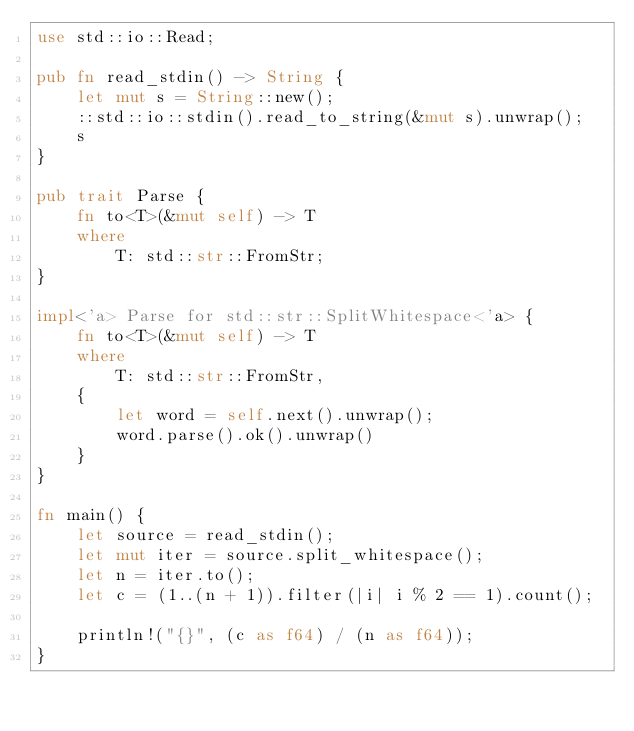Convert code to text. <code><loc_0><loc_0><loc_500><loc_500><_Rust_>use std::io::Read;

pub fn read_stdin() -> String {
    let mut s = String::new();
    ::std::io::stdin().read_to_string(&mut s).unwrap();
    s
}

pub trait Parse {
    fn to<T>(&mut self) -> T
    where
        T: std::str::FromStr;
}

impl<'a> Parse for std::str::SplitWhitespace<'a> {
    fn to<T>(&mut self) -> T
    where
        T: std::str::FromStr,
    {
        let word = self.next().unwrap();
        word.parse().ok().unwrap()
    }
}

fn main() {
    let source = read_stdin();
    let mut iter = source.split_whitespace();
    let n = iter.to();
    let c = (1..(n + 1)).filter(|i| i % 2 == 1).count();

    println!("{}", (c as f64) / (n as f64));
}</code> 